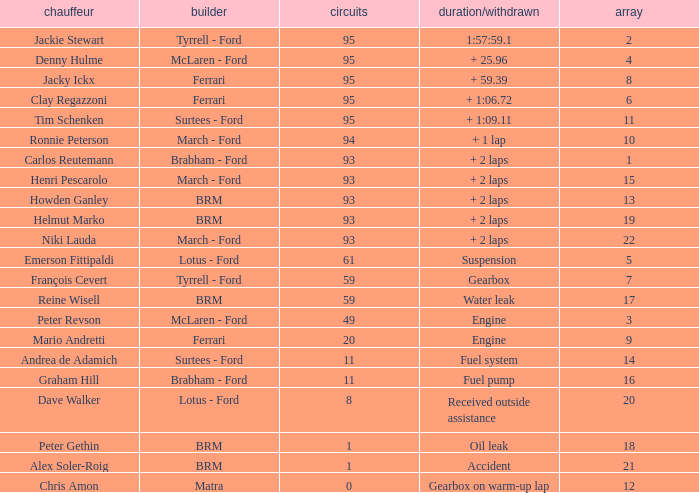How many grids does dave walker have? 1.0. 